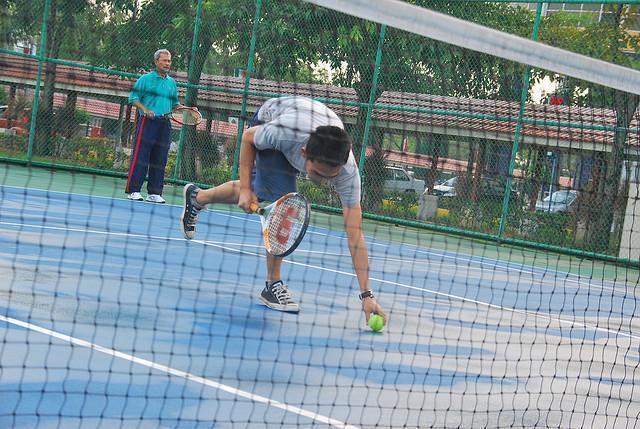Which company makes the green object here?
Select the accurate answer and provide explanation: 'Answer: answer
Rationale: rationale.'
Options: Wilson, coleco, kenner, timberland. Answer: wilson.
Rationale: Wilson makes the ball. 